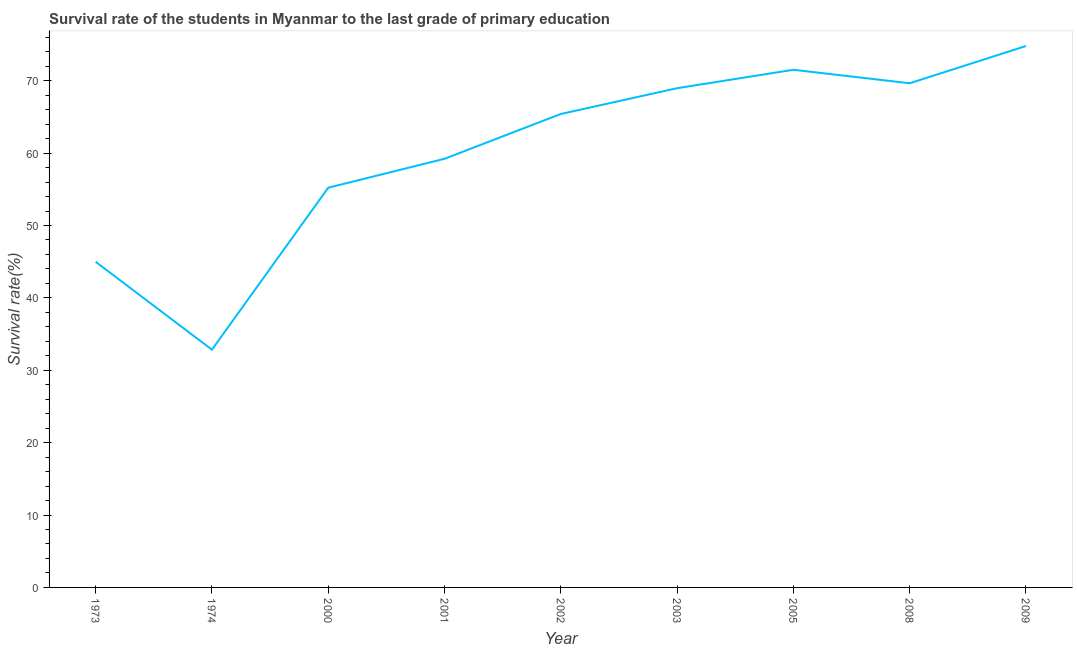What is the survival rate in primary education in 2009?
Your response must be concise. 74.79. Across all years, what is the maximum survival rate in primary education?
Provide a short and direct response. 74.79. Across all years, what is the minimum survival rate in primary education?
Keep it short and to the point. 32.84. In which year was the survival rate in primary education maximum?
Your answer should be compact. 2009. In which year was the survival rate in primary education minimum?
Provide a succinct answer. 1974. What is the sum of the survival rate in primary education?
Ensure brevity in your answer.  542.57. What is the difference between the survival rate in primary education in 2000 and 2005?
Keep it short and to the point. -16.29. What is the average survival rate in primary education per year?
Provide a short and direct response. 60.29. What is the median survival rate in primary education?
Your response must be concise. 65.4. Do a majority of the years between 2003 and 2002 (inclusive) have survival rate in primary education greater than 70 %?
Provide a succinct answer. No. What is the ratio of the survival rate in primary education in 2001 to that in 2009?
Make the answer very short. 0.79. Is the difference between the survival rate in primary education in 1973 and 2003 greater than the difference between any two years?
Your response must be concise. No. What is the difference between the highest and the second highest survival rate in primary education?
Keep it short and to the point. 3.28. What is the difference between the highest and the lowest survival rate in primary education?
Your answer should be compact. 41.95. In how many years, is the survival rate in primary education greater than the average survival rate in primary education taken over all years?
Keep it short and to the point. 5. Does the survival rate in primary education monotonically increase over the years?
Offer a terse response. No. How many lines are there?
Make the answer very short. 1. What is the difference between two consecutive major ticks on the Y-axis?
Make the answer very short. 10. What is the title of the graph?
Offer a terse response. Survival rate of the students in Myanmar to the last grade of primary education. What is the label or title of the Y-axis?
Your response must be concise. Survival rate(%). What is the Survival rate(%) of 1973?
Offer a terse response. 44.98. What is the Survival rate(%) in 1974?
Keep it short and to the point. 32.84. What is the Survival rate(%) of 2000?
Make the answer very short. 55.22. What is the Survival rate(%) in 2001?
Your answer should be very brief. 59.21. What is the Survival rate(%) in 2002?
Ensure brevity in your answer.  65.4. What is the Survival rate(%) in 2003?
Your response must be concise. 68.96. What is the Survival rate(%) in 2005?
Make the answer very short. 71.51. What is the Survival rate(%) in 2008?
Provide a short and direct response. 69.65. What is the Survival rate(%) in 2009?
Keep it short and to the point. 74.79. What is the difference between the Survival rate(%) in 1973 and 1974?
Give a very brief answer. 12.14. What is the difference between the Survival rate(%) in 1973 and 2000?
Make the answer very short. -10.23. What is the difference between the Survival rate(%) in 1973 and 2001?
Offer a terse response. -14.23. What is the difference between the Survival rate(%) in 1973 and 2002?
Keep it short and to the point. -20.42. What is the difference between the Survival rate(%) in 1973 and 2003?
Offer a terse response. -23.98. What is the difference between the Survival rate(%) in 1973 and 2005?
Make the answer very short. -26.53. What is the difference between the Survival rate(%) in 1973 and 2008?
Keep it short and to the point. -24.66. What is the difference between the Survival rate(%) in 1973 and 2009?
Your answer should be compact. -29.81. What is the difference between the Survival rate(%) in 1974 and 2000?
Your answer should be very brief. -22.38. What is the difference between the Survival rate(%) in 1974 and 2001?
Your answer should be compact. -26.37. What is the difference between the Survival rate(%) in 1974 and 2002?
Keep it short and to the point. -32.56. What is the difference between the Survival rate(%) in 1974 and 2003?
Your answer should be compact. -36.12. What is the difference between the Survival rate(%) in 1974 and 2005?
Make the answer very short. -38.67. What is the difference between the Survival rate(%) in 1974 and 2008?
Ensure brevity in your answer.  -36.8. What is the difference between the Survival rate(%) in 1974 and 2009?
Make the answer very short. -41.95. What is the difference between the Survival rate(%) in 2000 and 2001?
Your response must be concise. -4. What is the difference between the Survival rate(%) in 2000 and 2002?
Keep it short and to the point. -10.19. What is the difference between the Survival rate(%) in 2000 and 2003?
Offer a very short reply. -13.75. What is the difference between the Survival rate(%) in 2000 and 2005?
Keep it short and to the point. -16.29. What is the difference between the Survival rate(%) in 2000 and 2008?
Provide a succinct answer. -14.43. What is the difference between the Survival rate(%) in 2000 and 2009?
Ensure brevity in your answer.  -19.58. What is the difference between the Survival rate(%) in 2001 and 2002?
Offer a very short reply. -6.19. What is the difference between the Survival rate(%) in 2001 and 2003?
Offer a terse response. -9.75. What is the difference between the Survival rate(%) in 2001 and 2005?
Provide a succinct answer. -12.3. What is the difference between the Survival rate(%) in 2001 and 2008?
Give a very brief answer. -10.43. What is the difference between the Survival rate(%) in 2001 and 2009?
Your answer should be very brief. -15.58. What is the difference between the Survival rate(%) in 2002 and 2003?
Your answer should be compact. -3.56. What is the difference between the Survival rate(%) in 2002 and 2005?
Provide a succinct answer. -6.11. What is the difference between the Survival rate(%) in 2002 and 2008?
Offer a very short reply. -4.24. What is the difference between the Survival rate(%) in 2002 and 2009?
Provide a succinct answer. -9.39. What is the difference between the Survival rate(%) in 2003 and 2005?
Provide a succinct answer. -2.55. What is the difference between the Survival rate(%) in 2003 and 2008?
Ensure brevity in your answer.  -0.68. What is the difference between the Survival rate(%) in 2003 and 2009?
Your response must be concise. -5.83. What is the difference between the Survival rate(%) in 2005 and 2008?
Give a very brief answer. 1.86. What is the difference between the Survival rate(%) in 2005 and 2009?
Your answer should be very brief. -3.28. What is the difference between the Survival rate(%) in 2008 and 2009?
Give a very brief answer. -5.15. What is the ratio of the Survival rate(%) in 1973 to that in 1974?
Provide a short and direct response. 1.37. What is the ratio of the Survival rate(%) in 1973 to that in 2000?
Your response must be concise. 0.81. What is the ratio of the Survival rate(%) in 1973 to that in 2001?
Give a very brief answer. 0.76. What is the ratio of the Survival rate(%) in 1973 to that in 2002?
Your response must be concise. 0.69. What is the ratio of the Survival rate(%) in 1973 to that in 2003?
Provide a short and direct response. 0.65. What is the ratio of the Survival rate(%) in 1973 to that in 2005?
Make the answer very short. 0.63. What is the ratio of the Survival rate(%) in 1973 to that in 2008?
Keep it short and to the point. 0.65. What is the ratio of the Survival rate(%) in 1973 to that in 2009?
Provide a short and direct response. 0.6. What is the ratio of the Survival rate(%) in 1974 to that in 2000?
Your answer should be compact. 0.59. What is the ratio of the Survival rate(%) in 1974 to that in 2001?
Give a very brief answer. 0.56. What is the ratio of the Survival rate(%) in 1974 to that in 2002?
Your answer should be very brief. 0.5. What is the ratio of the Survival rate(%) in 1974 to that in 2003?
Provide a short and direct response. 0.48. What is the ratio of the Survival rate(%) in 1974 to that in 2005?
Provide a short and direct response. 0.46. What is the ratio of the Survival rate(%) in 1974 to that in 2008?
Offer a very short reply. 0.47. What is the ratio of the Survival rate(%) in 1974 to that in 2009?
Give a very brief answer. 0.44. What is the ratio of the Survival rate(%) in 2000 to that in 2001?
Your response must be concise. 0.93. What is the ratio of the Survival rate(%) in 2000 to that in 2002?
Provide a short and direct response. 0.84. What is the ratio of the Survival rate(%) in 2000 to that in 2003?
Offer a very short reply. 0.8. What is the ratio of the Survival rate(%) in 2000 to that in 2005?
Provide a succinct answer. 0.77. What is the ratio of the Survival rate(%) in 2000 to that in 2008?
Provide a short and direct response. 0.79. What is the ratio of the Survival rate(%) in 2000 to that in 2009?
Offer a very short reply. 0.74. What is the ratio of the Survival rate(%) in 2001 to that in 2002?
Your response must be concise. 0.91. What is the ratio of the Survival rate(%) in 2001 to that in 2003?
Provide a succinct answer. 0.86. What is the ratio of the Survival rate(%) in 2001 to that in 2005?
Your answer should be compact. 0.83. What is the ratio of the Survival rate(%) in 2001 to that in 2009?
Give a very brief answer. 0.79. What is the ratio of the Survival rate(%) in 2002 to that in 2003?
Provide a succinct answer. 0.95. What is the ratio of the Survival rate(%) in 2002 to that in 2005?
Offer a very short reply. 0.92. What is the ratio of the Survival rate(%) in 2002 to that in 2008?
Keep it short and to the point. 0.94. What is the ratio of the Survival rate(%) in 2002 to that in 2009?
Give a very brief answer. 0.87. What is the ratio of the Survival rate(%) in 2003 to that in 2005?
Offer a very short reply. 0.96. What is the ratio of the Survival rate(%) in 2003 to that in 2008?
Offer a terse response. 0.99. What is the ratio of the Survival rate(%) in 2003 to that in 2009?
Make the answer very short. 0.92. What is the ratio of the Survival rate(%) in 2005 to that in 2008?
Your answer should be very brief. 1.03. What is the ratio of the Survival rate(%) in 2005 to that in 2009?
Keep it short and to the point. 0.96. What is the ratio of the Survival rate(%) in 2008 to that in 2009?
Make the answer very short. 0.93. 